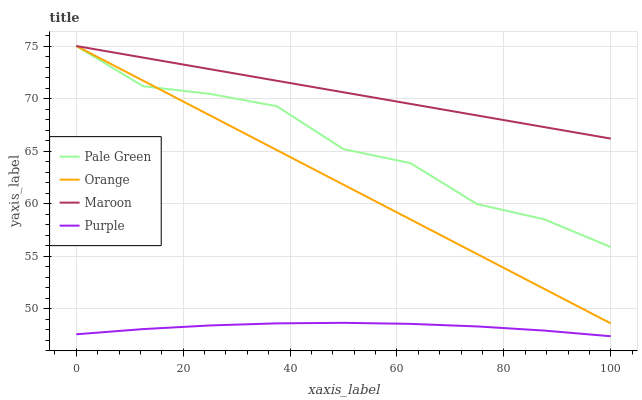Does Purple have the minimum area under the curve?
Answer yes or no. Yes. Does Maroon have the maximum area under the curve?
Answer yes or no. Yes. Does Pale Green have the minimum area under the curve?
Answer yes or no. No. Does Pale Green have the maximum area under the curve?
Answer yes or no. No. Is Maroon the smoothest?
Answer yes or no. Yes. Is Pale Green the roughest?
Answer yes or no. Yes. Is Purple the smoothest?
Answer yes or no. No. Is Purple the roughest?
Answer yes or no. No. Does Pale Green have the lowest value?
Answer yes or no. No. Does Maroon have the highest value?
Answer yes or no. Yes. Does Purple have the highest value?
Answer yes or no. No. Is Purple less than Orange?
Answer yes or no. Yes. Is Orange greater than Purple?
Answer yes or no. Yes. Does Pale Green intersect Orange?
Answer yes or no. Yes. Is Pale Green less than Orange?
Answer yes or no. No. Is Pale Green greater than Orange?
Answer yes or no. No. Does Purple intersect Orange?
Answer yes or no. No. 